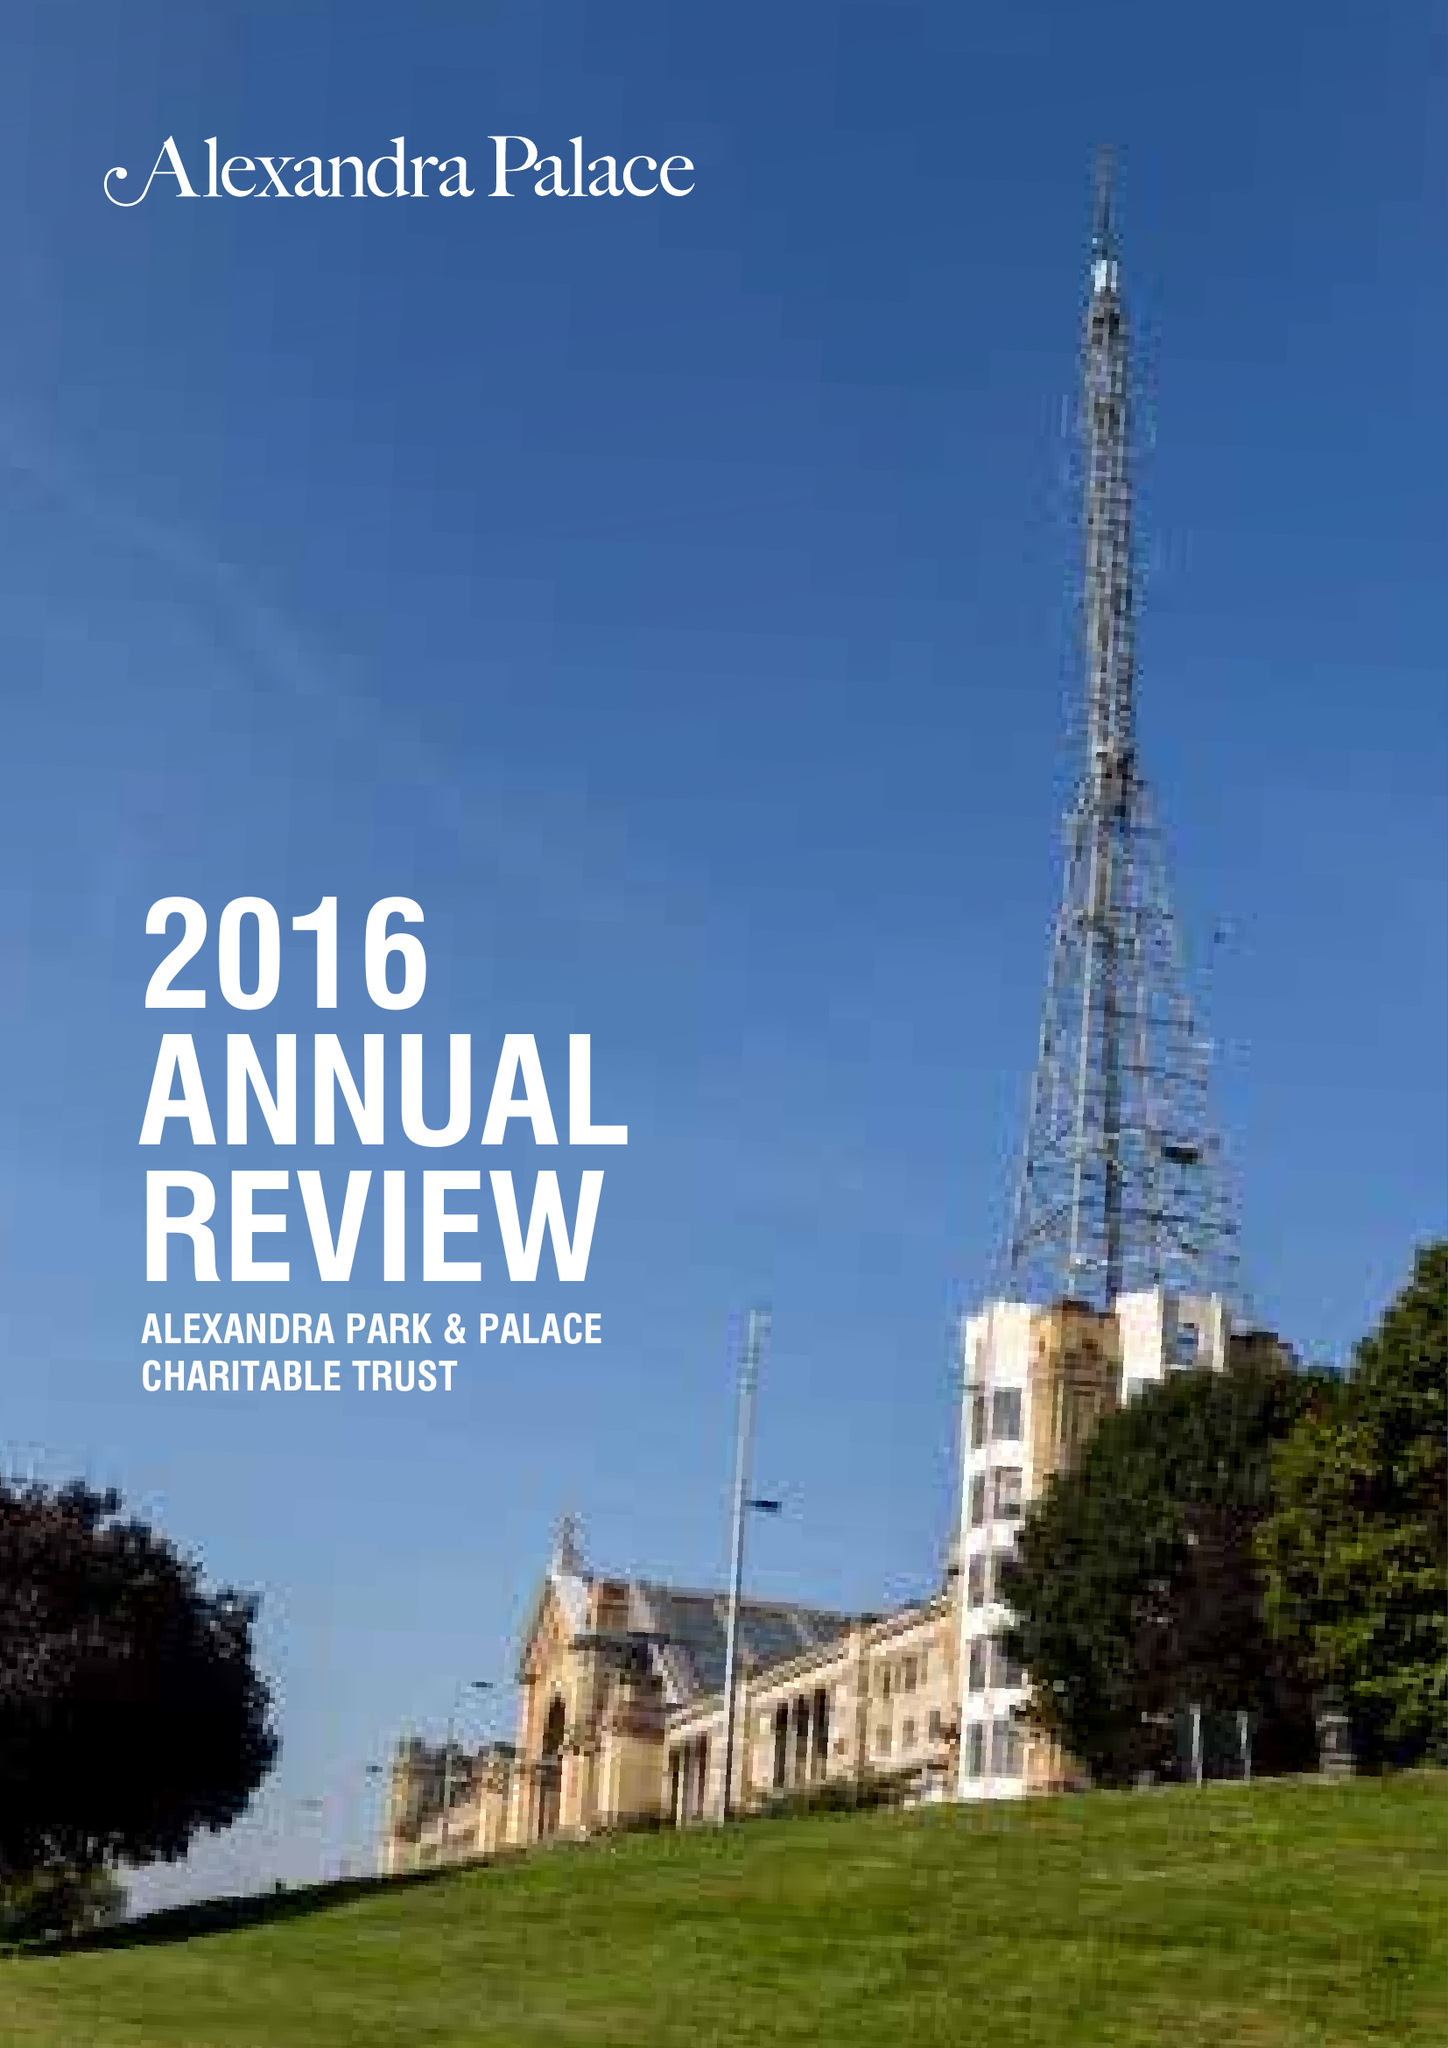What is the value for the spending_annually_in_british_pounds?
Answer the question using a single word or phrase. 15479000.00 